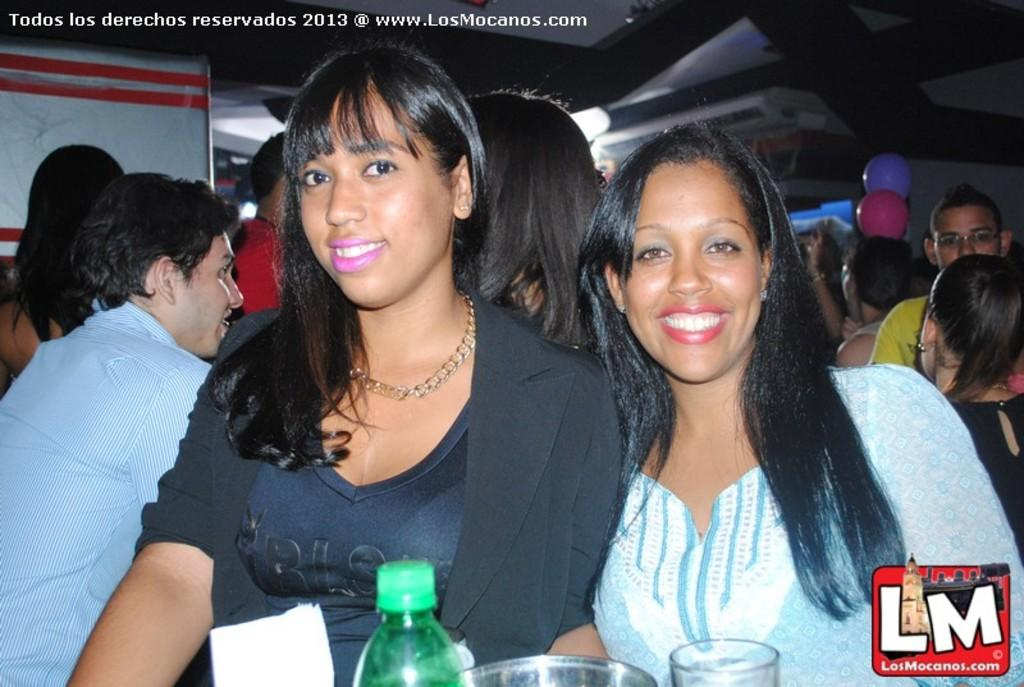What is the main subject of the image? There is a group of people in the image. What objects are on the table in the image? There is a bottle and glasses on the table in the image. What can be seen in the background of the image? Balloons are present in the background of the image. How many crates are visible in the image? There are no crates present in the image. What type of wheel can be seen on the table in the image? There are no wheels present on the table or in the image. 